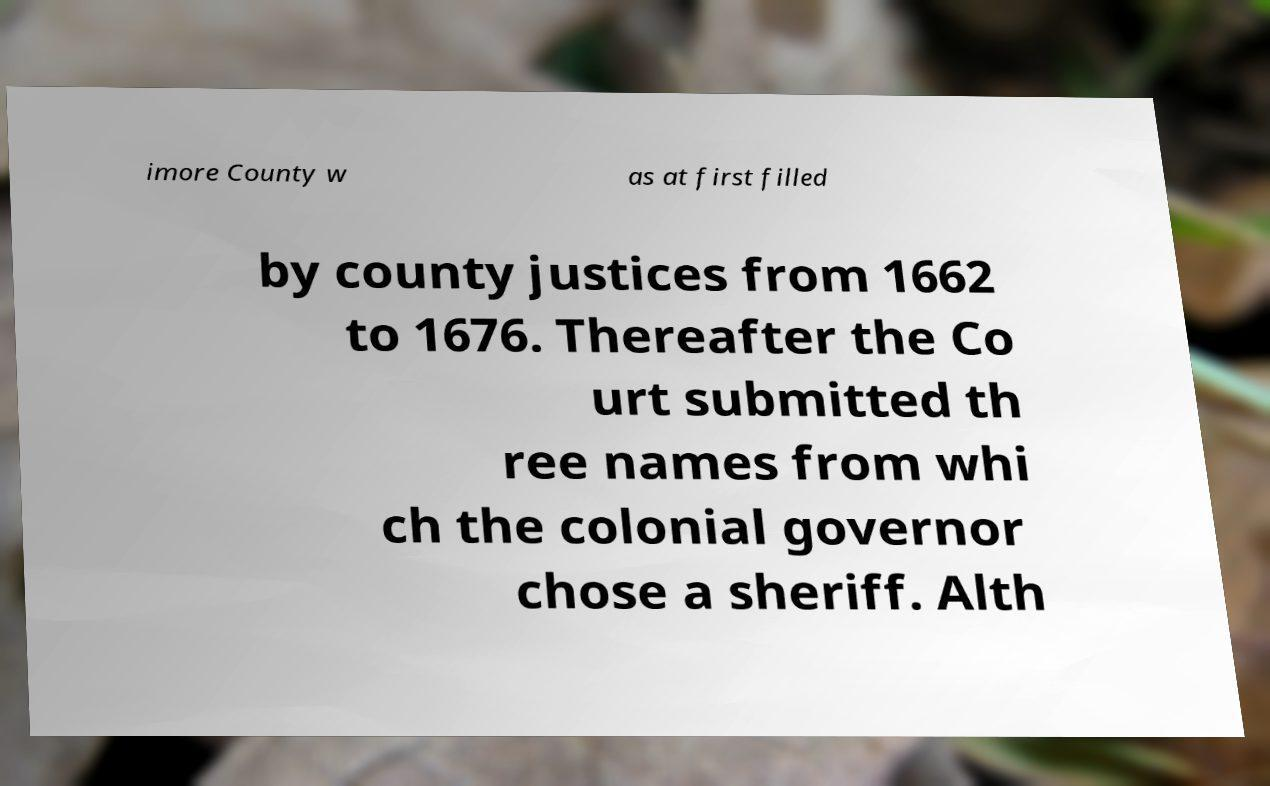Can you accurately transcribe the text from the provided image for me? imore County w as at first filled by county justices from 1662 to 1676. Thereafter the Co urt submitted th ree names from whi ch the colonial governor chose a sheriff. Alth 